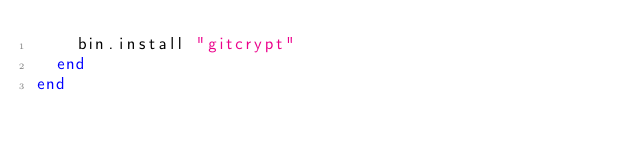<code> <loc_0><loc_0><loc_500><loc_500><_Ruby_>    bin.install "gitcrypt"
  end
end
</code> 